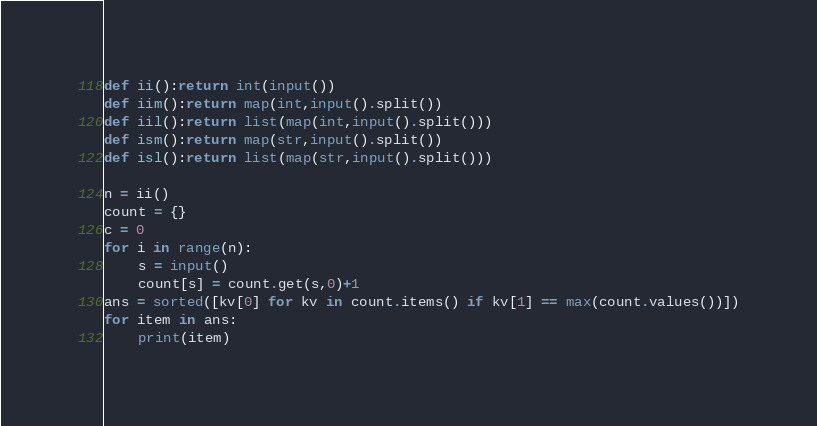Convert code to text. <code><loc_0><loc_0><loc_500><loc_500><_Python_>def ii():return int(input())
def iim():return map(int,input().split())
def iil():return list(map(int,input().split()))
def ism():return map(str,input().split())
def isl():return list(map(str,input().split()))

n = ii()
count = {}
c = 0
for i in range(n):
    s = input()
    count[s] = count.get(s,0)+1
ans = sorted([kv[0] for kv in count.items() if kv[1] == max(count.values())])
for item in ans:
    print(item)</code> 